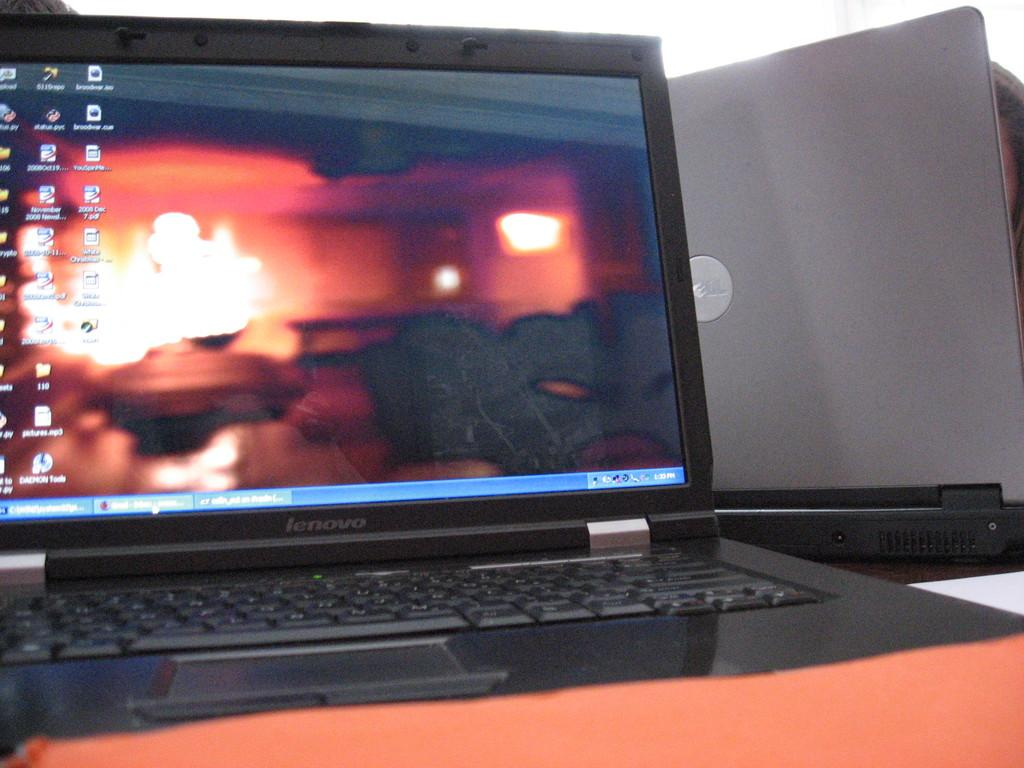<image>
Give a short and clear explanation of the subsequent image. A lenovo laptop has many icons on its home screen. 